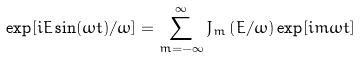<formula> <loc_0><loc_0><loc_500><loc_500>\exp [ i E \sin ( \omega t ) / \omega ] = \sum _ { m = - \infty } ^ { \infty } J _ { m } \left ( E / \omega \right ) \exp [ i m \omega t ]</formula> 